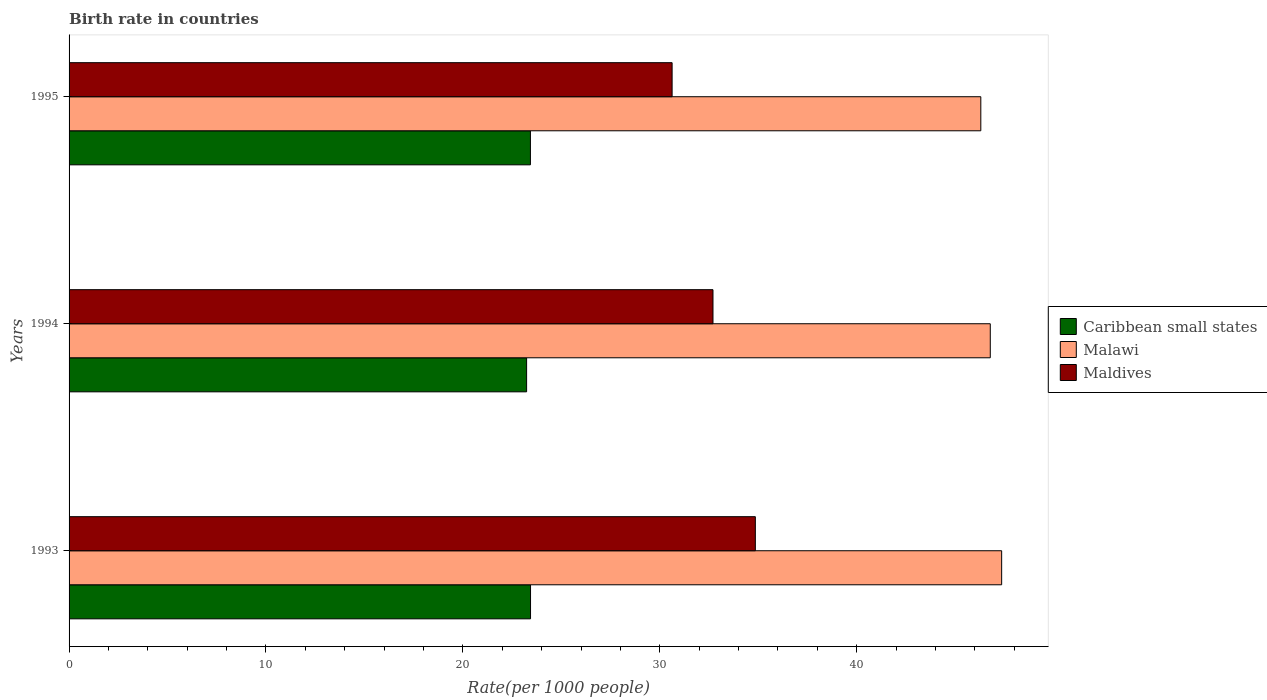How many groups of bars are there?
Give a very brief answer. 3. Are the number of bars per tick equal to the number of legend labels?
Ensure brevity in your answer.  Yes. How many bars are there on the 3rd tick from the top?
Offer a terse response. 3. In how many cases, is the number of bars for a given year not equal to the number of legend labels?
Offer a terse response. 0. What is the birth rate in Maldives in 1995?
Your answer should be compact. 30.62. Across all years, what is the maximum birth rate in Malawi?
Provide a succinct answer. 47.36. Across all years, what is the minimum birth rate in Caribbean small states?
Offer a very short reply. 23.24. In which year was the birth rate in Caribbean small states minimum?
Your response must be concise. 1994. What is the total birth rate in Caribbean small states in the graph?
Ensure brevity in your answer.  70.1. What is the difference between the birth rate in Caribbean small states in 1993 and that in 1994?
Your answer should be very brief. 0.2. What is the difference between the birth rate in Maldives in 1994 and the birth rate in Malawi in 1995?
Offer a terse response. -13.6. What is the average birth rate in Malawi per year?
Offer a terse response. 46.82. In the year 1994, what is the difference between the birth rate in Maldives and birth rate in Malawi?
Give a very brief answer. -14.08. In how many years, is the birth rate in Maldives greater than 32 ?
Keep it short and to the point. 2. What is the ratio of the birth rate in Malawi in 1994 to that in 1995?
Provide a short and direct response. 1.01. What is the difference between the highest and the second highest birth rate in Caribbean small states?
Provide a succinct answer. 0.01. What is the difference between the highest and the lowest birth rate in Malawi?
Offer a terse response. 1.06. What does the 2nd bar from the top in 1995 represents?
Ensure brevity in your answer.  Malawi. What does the 2nd bar from the bottom in 1993 represents?
Your response must be concise. Malawi. Is it the case that in every year, the sum of the birth rate in Caribbean small states and birth rate in Maldives is greater than the birth rate in Malawi?
Provide a succinct answer. Yes. How many bars are there?
Your response must be concise. 9. How many years are there in the graph?
Offer a very short reply. 3. Does the graph contain grids?
Your answer should be compact. No. How many legend labels are there?
Offer a terse response. 3. How are the legend labels stacked?
Make the answer very short. Vertical. What is the title of the graph?
Your answer should be compact. Birth rate in countries. What is the label or title of the X-axis?
Offer a very short reply. Rate(per 1000 people). What is the Rate(per 1000 people) of Caribbean small states in 1993?
Offer a terse response. 23.44. What is the Rate(per 1000 people) of Malawi in 1993?
Ensure brevity in your answer.  47.36. What is the Rate(per 1000 people) in Maldives in 1993?
Your answer should be very brief. 34.85. What is the Rate(per 1000 people) in Caribbean small states in 1994?
Ensure brevity in your answer.  23.24. What is the Rate(per 1000 people) in Malawi in 1994?
Your answer should be very brief. 46.78. What is the Rate(per 1000 people) in Maldives in 1994?
Your response must be concise. 32.7. What is the Rate(per 1000 people) in Caribbean small states in 1995?
Keep it short and to the point. 23.43. What is the Rate(per 1000 people) of Malawi in 1995?
Offer a terse response. 46.3. What is the Rate(per 1000 people) of Maldives in 1995?
Provide a short and direct response. 30.62. Across all years, what is the maximum Rate(per 1000 people) in Caribbean small states?
Offer a very short reply. 23.44. Across all years, what is the maximum Rate(per 1000 people) in Malawi?
Ensure brevity in your answer.  47.36. Across all years, what is the maximum Rate(per 1000 people) in Maldives?
Your answer should be compact. 34.85. Across all years, what is the minimum Rate(per 1000 people) in Caribbean small states?
Provide a short and direct response. 23.24. Across all years, what is the minimum Rate(per 1000 people) in Malawi?
Provide a succinct answer. 46.3. Across all years, what is the minimum Rate(per 1000 people) in Maldives?
Make the answer very short. 30.62. What is the total Rate(per 1000 people) in Caribbean small states in the graph?
Provide a short and direct response. 70.1. What is the total Rate(per 1000 people) in Malawi in the graph?
Offer a very short reply. 140.45. What is the total Rate(per 1000 people) in Maldives in the graph?
Provide a succinct answer. 98.18. What is the difference between the Rate(per 1000 people) of Caribbean small states in 1993 and that in 1994?
Provide a succinct answer. 0.2. What is the difference between the Rate(per 1000 people) of Malawi in 1993 and that in 1994?
Offer a very short reply. 0.58. What is the difference between the Rate(per 1000 people) of Maldives in 1993 and that in 1994?
Your response must be concise. 2.15. What is the difference between the Rate(per 1000 people) in Caribbean small states in 1993 and that in 1995?
Offer a very short reply. 0.01. What is the difference between the Rate(per 1000 people) in Malawi in 1993 and that in 1995?
Ensure brevity in your answer.  1.06. What is the difference between the Rate(per 1000 people) in Maldives in 1993 and that in 1995?
Make the answer very short. 4.23. What is the difference between the Rate(per 1000 people) in Caribbean small states in 1994 and that in 1995?
Give a very brief answer. -0.19. What is the difference between the Rate(per 1000 people) in Malawi in 1994 and that in 1995?
Keep it short and to the point. 0.48. What is the difference between the Rate(per 1000 people) of Maldives in 1994 and that in 1995?
Provide a succinct answer. 2.08. What is the difference between the Rate(per 1000 people) of Caribbean small states in 1993 and the Rate(per 1000 people) of Malawi in 1994?
Your answer should be compact. -23.35. What is the difference between the Rate(per 1000 people) of Caribbean small states in 1993 and the Rate(per 1000 people) of Maldives in 1994?
Give a very brief answer. -9.27. What is the difference between the Rate(per 1000 people) in Malawi in 1993 and the Rate(per 1000 people) in Maldives in 1994?
Your answer should be very brief. 14.66. What is the difference between the Rate(per 1000 people) of Caribbean small states in 1993 and the Rate(per 1000 people) of Malawi in 1995?
Provide a succinct answer. -22.87. What is the difference between the Rate(per 1000 people) in Caribbean small states in 1993 and the Rate(per 1000 people) in Maldives in 1995?
Provide a short and direct response. -7.19. What is the difference between the Rate(per 1000 people) of Malawi in 1993 and the Rate(per 1000 people) of Maldives in 1995?
Give a very brief answer. 16.74. What is the difference between the Rate(per 1000 people) of Caribbean small states in 1994 and the Rate(per 1000 people) of Malawi in 1995?
Give a very brief answer. -23.07. What is the difference between the Rate(per 1000 people) in Caribbean small states in 1994 and the Rate(per 1000 people) in Maldives in 1995?
Offer a very short reply. -7.39. What is the difference between the Rate(per 1000 people) in Malawi in 1994 and the Rate(per 1000 people) in Maldives in 1995?
Give a very brief answer. 16.16. What is the average Rate(per 1000 people) of Caribbean small states per year?
Provide a short and direct response. 23.37. What is the average Rate(per 1000 people) of Malawi per year?
Ensure brevity in your answer.  46.82. What is the average Rate(per 1000 people) of Maldives per year?
Keep it short and to the point. 32.73. In the year 1993, what is the difference between the Rate(per 1000 people) of Caribbean small states and Rate(per 1000 people) of Malawi?
Your answer should be compact. -23.93. In the year 1993, what is the difference between the Rate(per 1000 people) of Caribbean small states and Rate(per 1000 people) of Maldives?
Provide a succinct answer. -11.42. In the year 1993, what is the difference between the Rate(per 1000 people) in Malawi and Rate(per 1000 people) in Maldives?
Offer a very short reply. 12.51. In the year 1994, what is the difference between the Rate(per 1000 people) in Caribbean small states and Rate(per 1000 people) in Malawi?
Make the answer very short. -23.55. In the year 1994, what is the difference between the Rate(per 1000 people) in Caribbean small states and Rate(per 1000 people) in Maldives?
Make the answer very short. -9.47. In the year 1994, what is the difference between the Rate(per 1000 people) in Malawi and Rate(per 1000 people) in Maldives?
Ensure brevity in your answer.  14.08. In the year 1995, what is the difference between the Rate(per 1000 people) in Caribbean small states and Rate(per 1000 people) in Malawi?
Offer a very short reply. -22.87. In the year 1995, what is the difference between the Rate(per 1000 people) in Caribbean small states and Rate(per 1000 people) in Maldives?
Keep it short and to the point. -7.2. In the year 1995, what is the difference between the Rate(per 1000 people) in Malawi and Rate(per 1000 people) in Maldives?
Your answer should be very brief. 15.68. What is the ratio of the Rate(per 1000 people) in Caribbean small states in 1993 to that in 1994?
Keep it short and to the point. 1.01. What is the ratio of the Rate(per 1000 people) in Malawi in 1993 to that in 1994?
Ensure brevity in your answer.  1.01. What is the ratio of the Rate(per 1000 people) in Maldives in 1993 to that in 1994?
Keep it short and to the point. 1.07. What is the ratio of the Rate(per 1000 people) in Caribbean small states in 1993 to that in 1995?
Your answer should be very brief. 1. What is the ratio of the Rate(per 1000 people) of Malawi in 1993 to that in 1995?
Your answer should be very brief. 1.02. What is the ratio of the Rate(per 1000 people) of Maldives in 1993 to that in 1995?
Keep it short and to the point. 1.14. What is the ratio of the Rate(per 1000 people) in Malawi in 1994 to that in 1995?
Offer a terse response. 1.01. What is the ratio of the Rate(per 1000 people) of Maldives in 1994 to that in 1995?
Keep it short and to the point. 1.07. What is the difference between the highest and the second highest Rate(per 1000 people) in Caribbean small states?
Your response must be concise. 0.01. What is the difference between the highest and the second highest Rate(per 1000 people) in Malawi?
Ensure brevity in your answer.  0.58. What is the difference between the highest and the second highest Rate(per 1000 people) in Maldives?
Your answer should be compact. 2.15. What is the difference between the highest and the lowest Rate(per 1000 people) in Caribbean small states?
Offer a very short reply. 0.2. What is the difference between the highest and the lowest Rate(per 1000 people) of Malawi?
Give a very brief answer. 1.06. What is the difference between the highest and the lowest Rate(per 1000 people) in Maldives?
Keep it short and to the point. 4.23. 